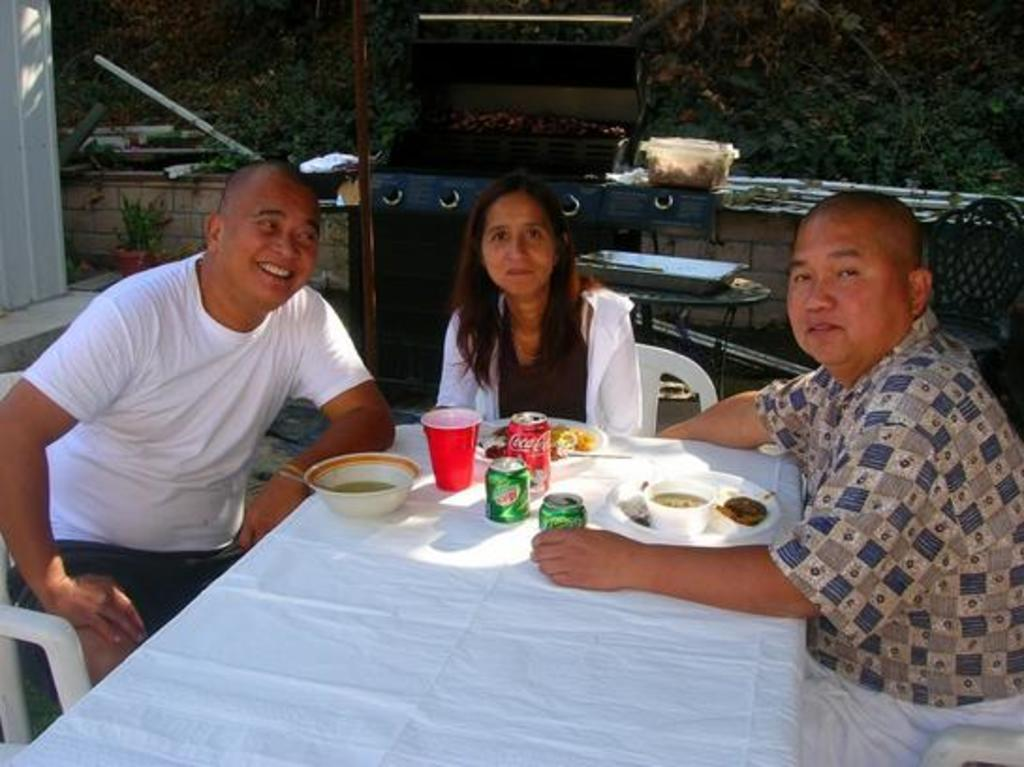How many people are in the image? There is a group of persons in the image. What are the persons in the image doing? The persons are having food and drinks. What can be seen in the background of the image? There is a wall and trees in the background of the image. How many snails can be seen crawling on the tongues of the persons in the image? There are no snails or tongues visible in the image; it only shows a group of persons having food and drinks. 